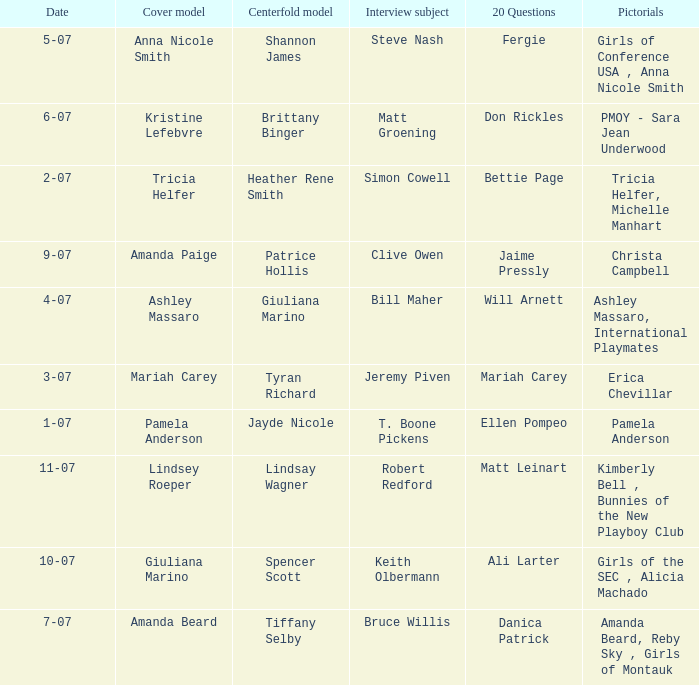Who was the centerfold model in the issue where Fergie answered the "20 questions"? Shannon James. 